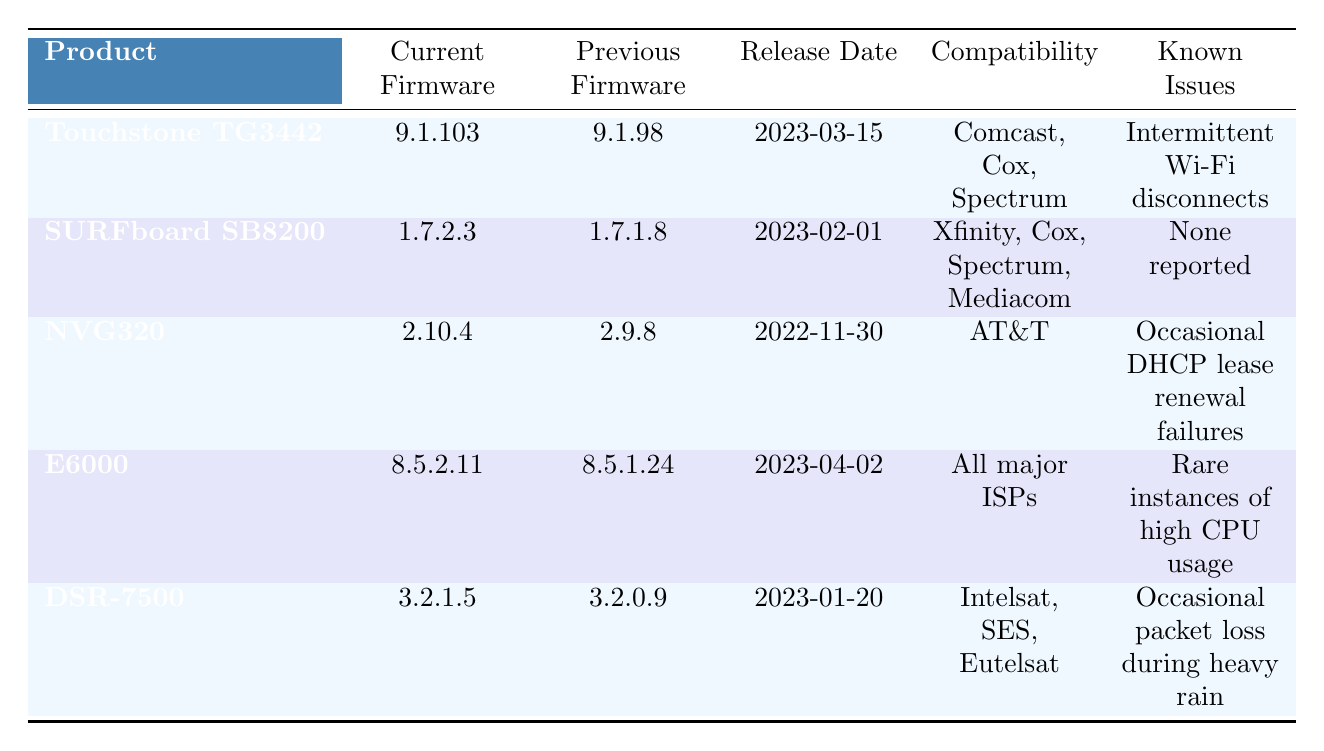What is the current firmware version for the Touchstone TG3442 Cable Modem? The current firmware version for the Touchstone TG3442 Cable Modem is listed in the table under the "Current Firmware" column as 9.1.103.
Answer: 9.1.103 What major ISPs is the E6000 Converged Edge Router compatible with? The table shows that the E6000 Converged Edge Router is compatible with "All major ISPs" in the compatibility column.
Answer: All major ISPs Which product was released most recently, and what is its release date? By inspecting the release dates in the table, the product released most recently is the Touchstone TG3442 Cable Modem with a release date of 2023-03-15.
Answer: Touchstone TG3442, 2023-03-15 Which product features added support for IPv6? The table indicates that the Touchstone TG3442 Cable Modem added "IPv6 support" in its features list.
Answer: Touchstone TG3442 How many products in the table have known issues related to Wi-Fi disconnects? Reviewing the "Known Issues" column, only the Touchstone TG3442 Cable Modem mentions "Intermittent Wi-Fi disconnects," indicating it has a known issue related to Wi-Fi disconnects.
Answer: 1 Is there a product that has "None reported" as its known issues? From the table, the SURFboard SB8200 DOCSIS 3.1 Cable Modem has "None reported" listed under known issues, confirming that it does not have any known issues.
Answer: Yes Which products underwent a firmware update that improved parental controls? The NVG320 Broadband Gateway is the only product listed with an improvement in "Improved parental controls" under the features added column.
Answer: NVG320 What is the difference in firmware versions between the current and previous firmware for the DSR-7500? The current firmware for the DSR-7500 is 3.2.1.5, while the previous firmware is 3.2.0.9. Subtracting these gives 3.2.1.5 - 3.2.0.9, which shows a difference of 0.0.1.
Answer: 0.0.1 How many products are compatible with Spectrum? By counting the compatibility entries under each product, both the Touchstone TG3442 and the SURFboard SB8200 are compatible with Spectrum. Hence, there are two products compatible with Spectrum.
Answer: 2 Which product has known issues related to "high CPU usage"? The table specifies that the E6000 Converged Edge Router has "Rare instances of high CPU usage" in the known issues section.
Answer: E6000 